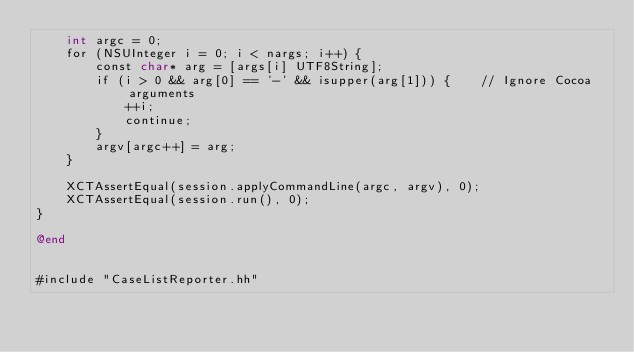Convert code to text. <code><loc_0><loc_0><loc_500><loc_500><_ObjectiveC_>    int argc = 0;
    for (NSUInteger i = 0; i < nargs; i++) {
        const char* arg = [args[i] UTF8String];
        if (i > 0 && arg[0] == '-' && isupper(arg[1])) {    // Ignore Cocoa arguments
            ++i;
            continue;
        }
        argv[argc++] = arg;
    }

    XCTAssertEqual(session.applyCommandLine(argc, argv), 0);
    XCTAssertEqual(session.run(), 0);
}

@end


#include "CaseListReporter.hh"
</code> 